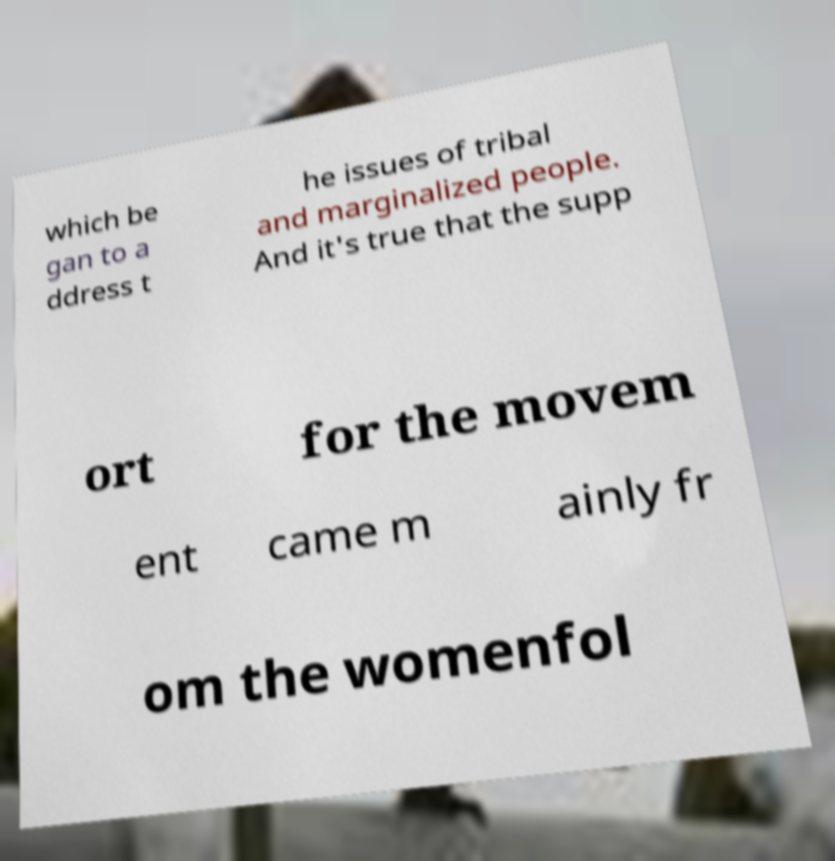Could you assist in decoding the text presented in this image and type it out clearly? which be gan to a ddress t he issues of tribal and marginalized people. And it's true that the supp ort for the movem ent came m ainly fr om the womenfol 